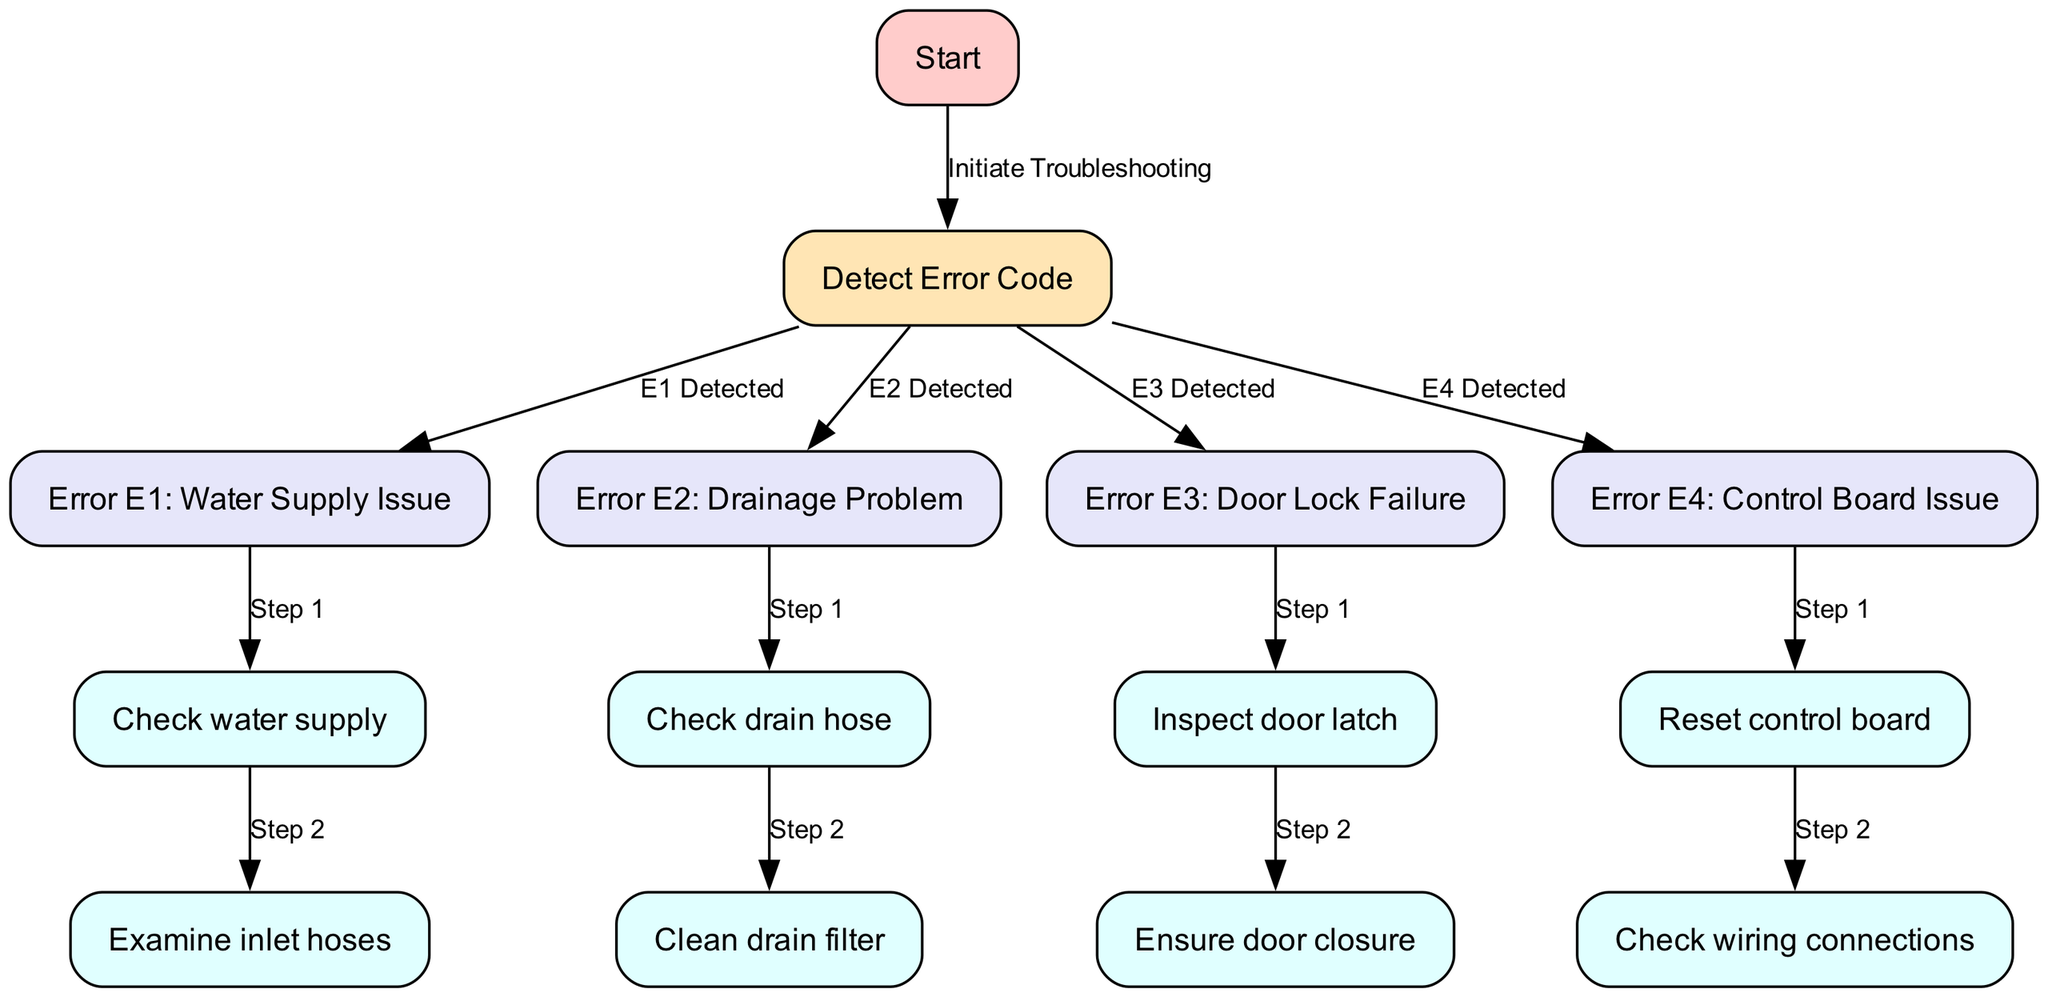What is the first node in the diagram? The first node in the diagram is 'Start', which is the entry point for troubleshooting the Monogram washer.
Answer: Start How many error codes are represented in the diagram? The diagram contains four error codes labeled E1, E2, E3, and E4. Each corresponds to a specific issue with the washer.
Answer: Four What is the last step for Error E1? The last step for Error E1 is 'Examine inlet hoses'. This follows the initial check of the water supply to resolve the issue.
Answer: Examine inlet hoses Which error code is associated with a drainage problem? Error E2 is the code associated with a drainage problem, guiding the user to check the drain hose first, followed by cleaning the drain filter.
Answer: E2 What action is taken after detecting Error E3? After detecting Error E3, the first action is to 'Inspect door latch' to ensure the door is functioning correctly, addressing the issue of door lock failure.
Answer: Inspect door latch What are the two steps for Error E4? The two steps for Error E4 are 'Reset control board' and 'Check wiring connections', which are necessary to troubleshoot a control board issue.
Answer: Reset control board, Check wiring connections How does one start troubleshooting any error code? Troubleshooting starts with the 'Detect Error Code' node, which is where users identify which specific error code has been triggered.
Answer: Detect Error Code What are the first two actions for resolving Error E2? The first two actions for Error E2 are to 'Check drain hose' followed by 'Clean drain filter' to fix the drainage problem.
Answer: Check drain hose, Clean drain filter What happens if Error E1 is detected in the washing machine? If Error E1 is detected, the user is instructed first to 'Check water supply', as this indicates a water supply issue that needs to be addressed.
Answer: Check water supply 